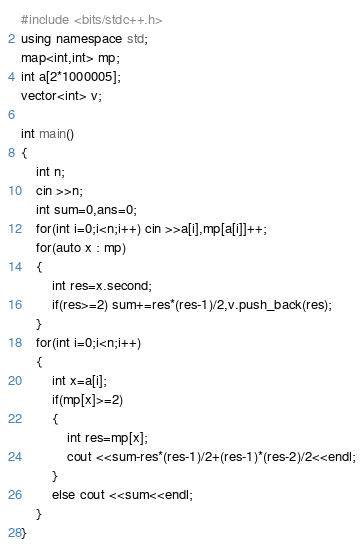<code> <loc_0><loc_0><loc_500><loc_500><_C++_>#include <bits/stdc++.h>
using namespace std;
map<int,int> mp;
int a[2*1000005];
vector<int> v;

int main()
{
	int n;
	cin >>n;
	int sum=0,ans=0;
	for(int i=0;i<n;i++) cin >>a[i],mp[a[i]]++;
	for(auto x : mp)
	{
		int res=x.second;
		if(res>=2) sum+=res*(res-1)/2,v.push_back(res);
	}
	for(int i=0;i<n;i++)
	{
		int x=a[i];
		if(mp[x]>=2)
		{
			int res=mp[x];
			cout <<sum-res*(res-1)/2+(res-1)*(res-2)/2<<endl;
		}
		else cout <<sum<<endl;
	}
}</code> 